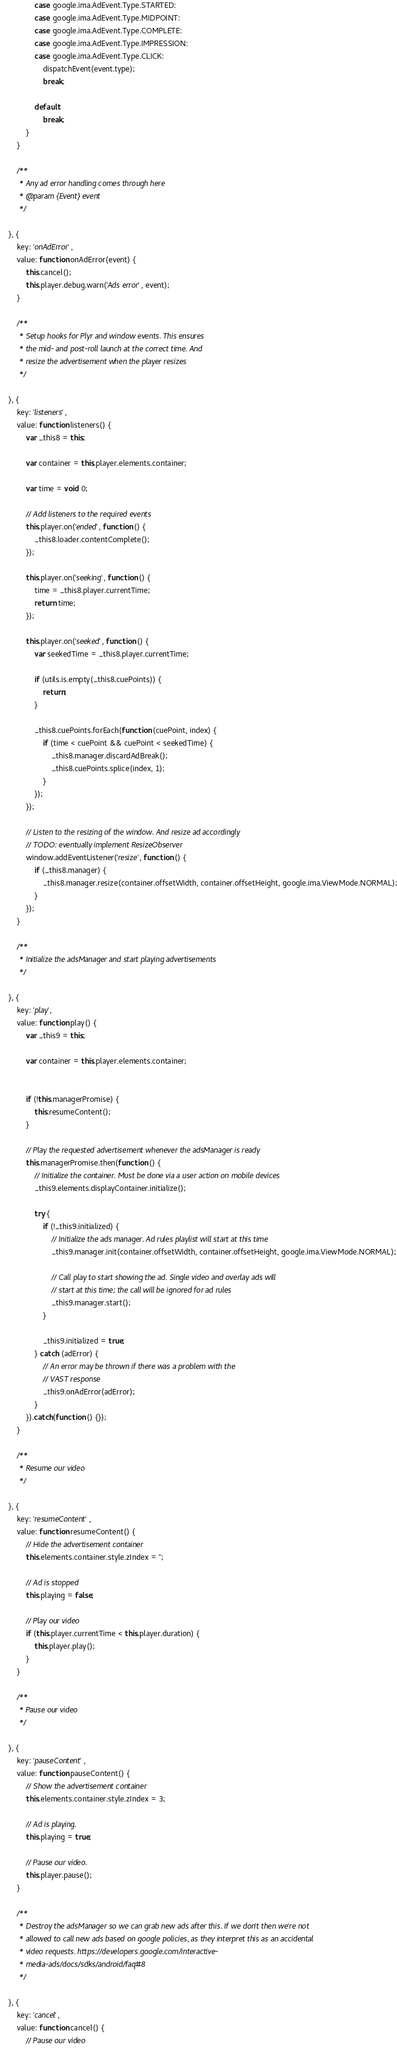Convert code to text. <code><loc_0><loc_0><loc_500><loc_500><_JavaScript_>
                case google.ima.AdEvent.Type.STARTED:
                case google.ima.AdEvent.Type.MIDPOINT:
                case google.ima.AdEvent.Type.COMPLETE:
                case google.ima.AdEvent.Type.IMPRESSION:
                case google.ima.AdEvent.Type.CLICK:
                    dispatchEvent(event.type);
                    break;

                default:
                    break;
            }
        }

        /**
         * Any ad error handling comes through here
         * @param {Event} event
         */

    }, {
        key: 'onAdError',
        value: function onAdError(event) {
            this.cancel();
            this.player.debug.warn('Ads error', event);
        }

        /**
         * Setup hooks for Plyr and window events. This ensures
         * the mid- and post-roll launch at the correct time. And
         * resize the advertisement when the player resizes
         */

    }, {
        key: 'listeners',
        value: function listeners() {
            var _this8 = this;

            var container = this.player.elements.container;

            var time = void 0;

            // Add listeners to the required events
            this.player.on('ended', function () {
                _this8.loader.contentComplete();
            });

            this.player.on('seeking', function () {
                time = _this8.player.currentTime;
                return time;
            });

            this.player.on('seeked', function () {
                var seekedTime = _this8.player.currentTime;

                if (utils.is.empty(_this8.cuePoints)) {
                    return;
                }

                _this8.cuePoints.forEach(function (cuePoint, index) {
                    if (time < cuePoint && cuePoint < seekedTime) {
                        _this8.manager.discardAdBreak();
                        _this8.cuePoints.splice(index, 1);
                    }
                });
            });

            // Listen to the resizing of the window. And resize ad accordingly
            // TODO: eventually implement ResizeObserver
            window.addEventListener('resize', function () {
                if (_this8.manager) {
                    _this8.manager.resize(container.offsetWidth, container.offsetHeight, google.ima.ViewMode.NORMAL);
                }
            });
        }

        /**
         * Initialize the adsManager and start playing advertisements
         */

    }, {
        key: 'play',
        value: function play() {
            var _this9 = this;

            var container = this.player.elements.container;


            if (!this.managerPromise) {
                this.resumeContent();
            }

            // Play the requested advertisement whenever the adsManager is ready
            this.managerPromise.then(function () {
                // Initialize the container. Must be done via a user action on mobile devices
                _this9.elements.displayContainer.initialize();

                try {
                    if (!_this9.initialized) {
                        // Initialize the ads manager. Ad rules playlist will start at this time
                        _this9.manager.init(container.offsetWidth, container.offsetHeight, google.ima.ViewMode.NORMAL);

                        // Call play to start showing the ad. Single video and overlay ads will
                        // start at this time; the call will be ignored for ad rules
                        _this9.manager.start();
                    }

                    _this9.initialized = true;
                } catch (adError) {
                    // An error may be thrown if there was a problem with the
                    // VAST response
                    _this9.onAdError(adError);
                }
            }).catch(function () {});
        }

        /**
         * Resume our video
         */

    }, {
        key: 'resumeContent',
        value: function resumeContent() {
            // Hide the advertisement container
            this.elements.container.style.zIndex = '';

            // Ad is stopped
            this.playing = false;

            // Play our video
            if (this.player.currentTime < this.player.duration) {
                this.player.play();
            }
        }

        /**
         * Pause our video
         */

    }, {
        key: 'pauseContent',
        value: function pauseContent() {
            // Show the advertisement container
            this.elements.container.style.zIndex = 3;

            // Ad is playing.
            this.playing = true;

            // Pause our video.
            this.player.pause();
        }

        /**
         * Destroy the adsManager so we can grab new ads after this. If we don't then we're not
         * allowed to call new ads based on google policies, as they interpret this as an accidental
         * video requests. https://developers.google.com/interactive-
         * media-ads/docs/sdks/android/faq#8
         */

    }, {
        key: 'cancel',
        value: function cancel() {
            // Pause our video</code> 